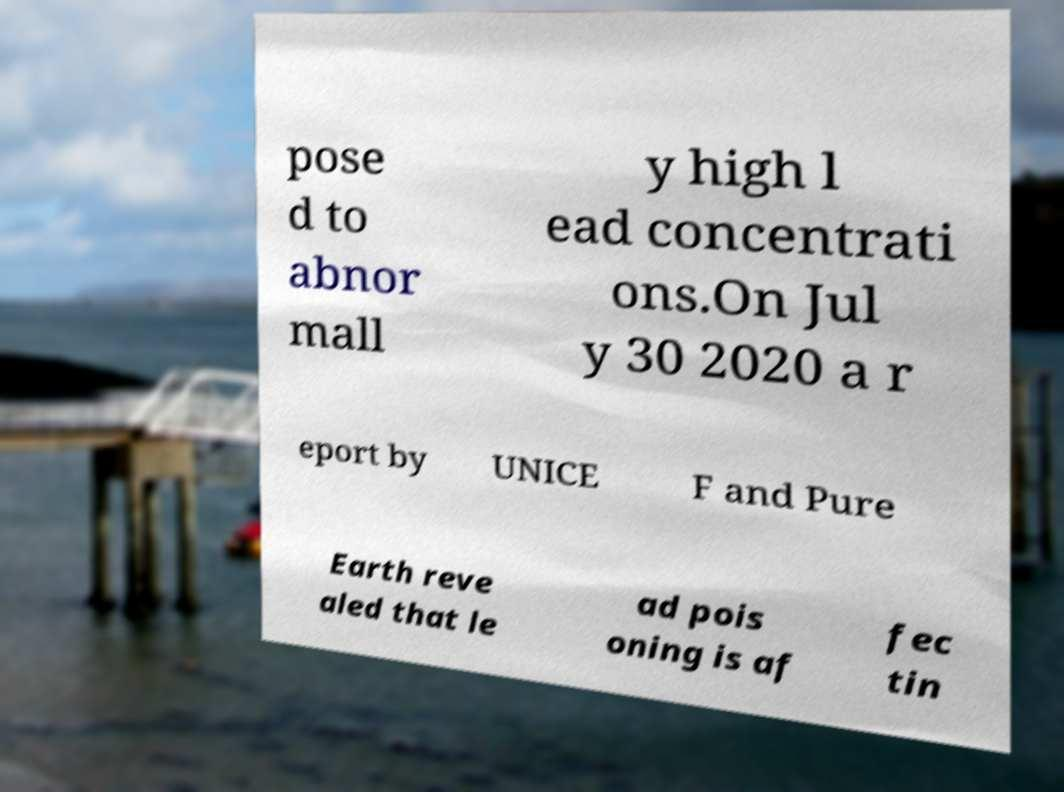I need the written content from this picture converted into text. Can you do that? pose d to abnor mall y high l ead concentrati ons.On Jul y 30 2020 a r eport by UNICE F and Pure Earth reve aled that le ad pois oning is af fec tin 